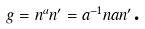Convert formula to latex. <formula><loc_0><loc_0><loc_500><loc_500>g = n ^ { a } n ^ { \prime } = a ^ { - 1 } n a n ^ { \prime } \text {.}</formula> 